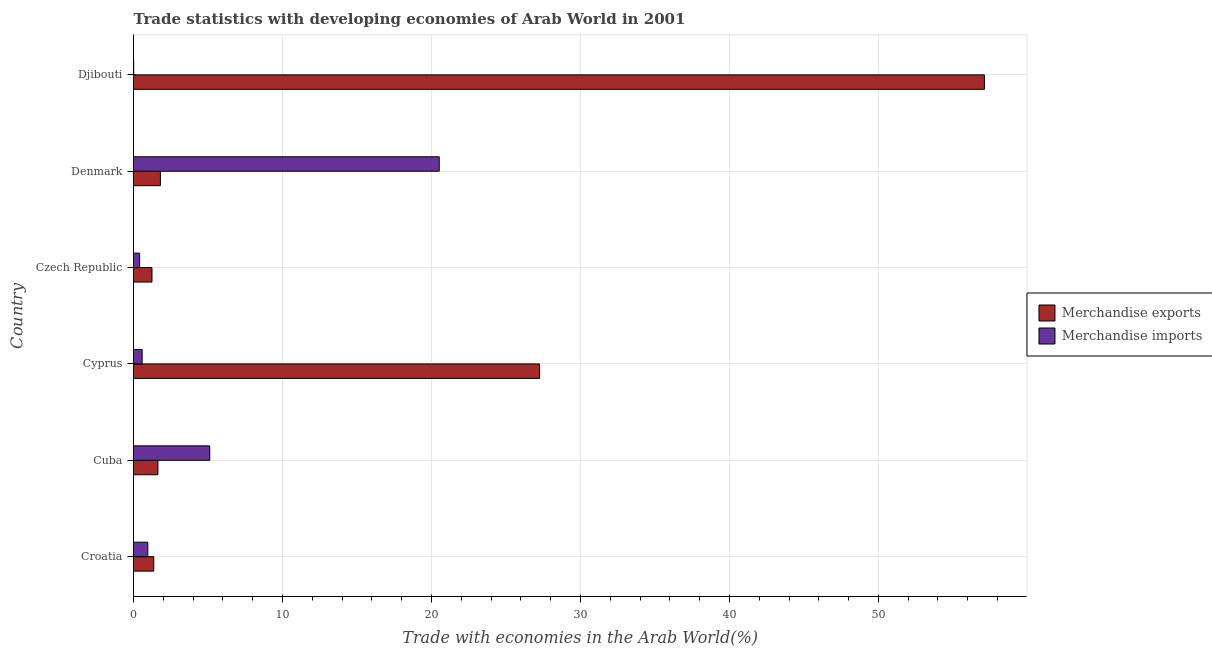How many groups of bars are there?
Your response must be concise. 6. Are the number of bars on each tick of the Y-axis equal?
Ensure brevity in your answer.  Yes. How many bars are there on the 3rd tick from the bottom?
Your answer should be compact. 2. What is the label of the 6th group of bars from the top?
Your answer should be compact. Croatia. What is the merchandise imports in Croatia?
Keep it short and to the point. 0.96. Across all countries, what is the maximum merchandise imports?
Your answer should be compact. 20.52. Across all countries, what is the minimum merchandise exports?
Ensure brevity in your answer.  1.24. In which country was the merchandise imports maximum?
Provide a short and direct response. Denmark. In which country was the merchandise imports minimum?
Your response must be concise. Djibouti. What is the total merchandise exports in the graph?
Your answer should be very brief. 90.42. What is the difference between the merchandise imports in Cuba and that in Denmark?
Make the answer very short. -15.4. What is the difference between the merchandise imports in Cuba and the merchandise exports in Denmark?
Provide a short and direct response. 3.31. What is the difference between the merchandise exports and merchandise imports in Czech Republic?
Give a very brief answer. 0.83. In how many countries, is the merchandise imports greater than 16 %?
Your response must be concise. 1. What is the ratio of the merchandise imports in Cyprus to that in Denmark?
Offer a terse response. 0.03. Is the difference between the merchandise imports in Croatia and Cyprus greater than the difference between the merchandise exports in Croatia and Cyprus?
Make the answer very short. Yes. What is the difference between the highest and the second highest merchandise imports?
Offer a very short reply. 15.4. What is the difference between the highest and the lowest merchandise imports?
Keep it short and to the point. 20.51. Is the sum of the merchandise exports in Cyprus and Djibouti greater than the maximum merchandise imports across all countries?
Provide a short and direct response. Yes. What does the 2nd bar from the top in Djibouti represents?
Make the answer very short. Merchandise exports. What does the 1st bar from the bottom in Croatia represents?
Your response must be concise. Merchandise exports. How many countries are there in the graph?
Offer a terse response. 6. Are the values on the major ticks of X-axis written in scientific E-notation?
Provide a succinct answer. No. Does the graph contain any zero values?
Your answer should be compact. No. Does the graph contain grids?
Offer a terse response. Yes. How many legend labels are there?
Provide a succinct answer. 2. What is the title of the graph?
Your response must be concise. Trade statistics with developing economies of Arab World in 2001. Does "Forest" appear as one of the legend labels in the graph?
Your answer should be very brief. No. What is the label or title of the X-axis?
Your answer should be compact. Trade with economies in the Arab World(%). What is the label or title of the Y-axis?
Your answer should be compact. Country. What is the Trade with economies in the Arab World(%) of Merchandise exports in Croatia?
Give a very brief answer. 1.36. What is the Trade with economies in the Arab World(%) of Merchandise imports in Croatia?
Your answer should be very brief. 0.96. What is the Trade with economies in the Arab World(%) of Merchandise exports in Cuba?
Provide a short and direct response. 1.64. What is the Trade with economies in the Arab World(%) in Merchandise imports in Cuba?
Your answer should be compact. 5.12. What is the Trade with economies in the Arab World(%) of Merchandise exports in Cyprus?
Your answer should be compact. 27.26. What is the Trade with economies in the Arab World(%) of Merchandise imports in Cyprus?
Give a very brief answer. 0.58. What is the Trade with economies in the Arab World(%) in Merchandise exports in Czech Republic?
Keep it short and to the point. 1.24. What is the Trade with economies in the Arab World(%) in Merchandise imports in Czech Republic?
Provide a succinct answer. 0.41. What is the Trade with economies in the Arab World(%) in Merchandise exports in Denmark?
Offer a terse response. 1.81. What is the Trade with economies in the Arab World(%) of Merchandise imports in Denmark?
Your answer should be very brief. 20.52. What is the Trade with economies in the Arab World(%) in Merchandise exports in Djibouti?
Offer a terse response. 57.12. What is the Trade with economies in the Arab World(%) in Merchandise imports in Djibouti?
Keep it short and to the point. 0.01. Across all countries, what is the maximum Trade with economies in the Arab World(%) in Merchandise exports?
Make the answer very short. 57.12. Across all countries, what is the maximum Trade with economies in the Arab World(%) of Merchandise imports?
Make the answer very short. 20.52. Across all countries, what is the minimum Trade with economies in the Arab World(%) of Merchandise exports?
Make the answer very short. 1.24. Across all countries, what is the minimum Trade with economies in the Arab World(%) in Merchandise imports?
Offer a very short reply. 0.01. What is the total Trade with economies in the Arab World(%) in Merchandise exports in the graph?
Offer a very short reply. 90.42. What is the total Trade with economies in the Arab World(%) in Merchandise imports in the graph?
Make the answer very short. 27.6. What is the difference between the Trade with economies in the Arab World(%) of Merchandise exports in Croatia and that in Cuba?
Provide a succinct answer. -0.28. What is the difference between the Trade with economies in the Arab World(%) in Merchandise imports in Croatia and that in Cuba?
Offer a very short reply. -4.16. What is the difference between the Trade with economies in the Arab World(%) of Merchandise exports in Croatia and that in Cyprus?
Make the answer very short. -25.9. What is the difference between the Trade with economies in the Arab World(%) in Merchandise imports in Croatia and that in Cyprus?
Give a very brief answer. 0.38. What is the difference between the Trade with economies in the Arab World(%) in Merchandise exports in Croatia and that in Czech Republic?
Offer a terse response. 0.12. What is the difference between the Trade with economies in the Arab World(%) in Merchandise imports in Croatia and that in Czech Republic?
Provide a short and direct response. 0.55. What is the difference between the Trade with economies in the Arab World(%) in Merchandise exports in Croatia and that in Denmark?
Your answer should be very brief. -0.45. What is the difference between the Trade with economies in the Arab World(%) of Merchandise imports in Croatia and that in Denmark?
Provide a succinct answer. -19.56. What is the difference between the Trade with economies in the Arab World(%) in Merchandise exports in Croatia and that in Djibouti?
Offer a very short reply. -55.76. What is the difference between the Trade with economies in the Arab World(%) in Merchandise imports in Croatia and that in Djibouti?
Provide a short and direct response. 0.95. What is the difference between the Trade with economies in the Arab World(%) of Merchandise exports in Cuba and that in Cyprus?
Your answer should be very brief. -25.62. What is the difference between the Trade with economies in the Arab World(%) of Merchandise imports in Cuba and that in Cyprus?
Your answer should be very brief. 4.54. What is the difference between the Trade with economies in the Arab World(%) in Merchandise exports in Cuba and that in Czech Republic?
Ensure brevity in your answer.  0.4. What is the difference between the Trade with economies in the Arab World(%) in Merchandise imports in Cuba and that in Czech Republic?
Make the answer very short. 4.7. What is the difference between the Trade with economies in the Arab World(%) in Merchandise exports in Cuba and that in Denmark?
Keep it short and to the point. -0.17. What is the difference between the Trade with economies in the Arab World(%) of Merchandise imports in Cuba and that in Denmark?
Your answer should be compact. -15.41. What is the difference between the Trade with economies in the Arab World(%) of Merchandise exports in Cuba and that in Djibouti?
Ensure brevity in your answer.  -55.48. What is the difference between the Trade with economies in the Arab World(%) in Merchandise imports in Cuba and that in Djibouti?
Your response must be concise. 5.11. What is the difference between the Trade with economies in the Arab World(%) of Merchandise exports in Cyprus and that in Czech Republic?
Your response must be concise. 26.02. What is the difference between the Trade with economies in the Arab World(%) of Merchandise imports in Cyprus and that in Czech Republic?
Ensure brevity in your answer.  0.17. What is the difference between the Trade with economies in the Arab World(%) of Merchandise exports in Cyprus and that in Denmark?
Provide a short and direct response. 25.45. What is the difference between the Trade with economies in the Arab World(%) in Merchandise imports in Cyprus and that in Denmark?
Your response must be concise. -19.94. What is the difference between the Trade with economies in the Arab World(%) of Merchandise exports in Cyprus and that in Djibouti?
Your answer should be very brief. -29.86. What is the difference between the Trade with economies in the Arab World(%) of Merchandise imports in Cyprus and that in Djibouti?
Offer a very short reply. 0.57. What is the difference between the Trade with economies in the Arab World(%) in Merchandise exports in Czech Republic and that in Denmark?
Your answer should be very brief. -0.57. What is the difference between the Trade with economies in the Arab World(%) in Merchandise imports in Czech Republic and that in Denmark?
Provide a succinct answer. -20.11. What is the difference between the Trade with economies in the Arab World(%) of Merchandise exports in Czech Republic and that in Djibouti?
Your answer should be very brief. -55.88. What is the difference between the Trade with economies in the Arab World(%) in Merchandise imports in Czech Republic and that in Djibouti?
Offer a very short reply. 0.4. What is the difference between the Trade with economies in the Arab World(%) of Merchandise exports in Denmark and that in Djibouti?
Make the answer very short. -55.31. What is the difference between the Trade with economies in the Arab World(%) in Merchandise imports in Denmark and that in Djibouti?
Ensure brevity in your answer.  20.51. What is the difference between the Trade with economies in the Arab World(%) in Merchandise exports in Croatia and the Trade with economies in the Arab World(%) in Merchandise imports in Cuba?
Your answer should be very brief. -3.76. What is the difference between the Trade with economies in the Arab World(%) in Merchandise exports in Croatia and the Trade with economies in the Arab World(%) in Merchandise imports in Cyprus?
Offer a terse response. 0.78. What is the difference between the Trade with economies in the Arab World(%) in Merchandise exports in Croatia and the Trade with economies in the Arab World(%) in Merchandise imports in Czech Republic?
Keep it short and to the point. 0.95. What is the difference between the Trade with economies in the Arab World(%) in Merchandise exports in Croatia and the Trade with economies in the Arab World(%) in Merchandise imports in Denmark?
Provide a succinct answer. -19.16. What is the difference between the Trade with economies in the Arab World(%) of Merchandise exports in Croatia and the Trade with economies in the Arab World(%) of Merchandise imports in Djibouti?
Your answer should be compact. 1.35. What is the difference between the Trade with economies in the Arab World(%) of Merchandise exports in Cuba and the Trade with economies in the Arab World(%) of Merchandise imports in Cyprus?
Your answer should be compact. 1.06. What is the difference between the Trade with economies in the Arab World(%) of Merchandise exports in Cuba and the Trade with economies in the Arab World(%) of Merchandise imports in Czech Republic?
Ensure brevity in your answer.  1.23. What is the difference between the Trade with economies in the Arab World(%) in Merchandise exports in Cuba and the Trade with economies in the Arab World(%) in Merchandise imports in Denmark?
Provide a short and direct response. -18.88. What is the difference between the Trade with economies in the Arab World(%) in Merchandise exports in Cuba and the Trade with economies in the Arab World(%) in Merchandise imports in Djibouti?
Provide a short and direct response. 1.63. What is the difference between the Trade with economies in the Arab World(%) in Merchandise exports in Cyprus and the Trade with economies in the Arab World(%) in Merchandise imports in Czech Republic?
Provide a short and direct response. 26.85. What is the difference between the Trade with economies in the Arab World(%) of Merchandise exports in Cyprus and the Trade with economies in the Arab World(%) of Merchandise imports in Denmark?
Keep it short and to the point. 6.73. What is the difference between the Trade with economies in the Arab World(%) of Merchandise exports in Cyprus and the Trade with economies in the Arab World(%) of Merchandise imports in Djibouti?
Your response must be concise. 27.25. What is the difference between the Trade with economies in the Arab World(%) of Merchandise exports in Czech Republic and the Trade with economies in the Arab World(%) of Merchandise imports in Denmark?
Give a very brief answer. -19.28. What is the difference between the Trade with economies in the Arab World(%) of Merchandise exports in Czech Republic and the Trade with economies in the Arab World(%) of Merchandise imports in Djibouti?
Offer a terse response. 1.23. What is the difference between the Trade with economies in the Arab World(%) of Merchandise exports in Denmark and the Trade with economies in the Arab World(%) of Merchandise imports in Djibouti?
Offer a very short reply. 1.8. What is the average Trade with economies in the Arab World(%) in Merchandise exports per country?
Provide a succinct answer. 15.07. What is the average Trade with economies in the Arab World(%) of Merchandise imports per country?
Provide a short and direct response. 4.6. What is the difference between the Trade with economies in the Arab World(%) of Merchandise exports and Trade with economies in the Arab World(%) of Merchandise imports in Croatia?
Your answer should be very brief. 0.4. What is the difference between the Trade with economies in the Arab World(%) in Merchandise exports and Trade with economies in the Arab World(%) in Merchandise imports in Cuba?
Provide a succinct answer. -3.48. What is the difference between the Trade with economies in the Arab World(%) of Merchandise exports and Trade with economies in the Arab World(%) of Merchandise imports in Cyprus?
Provide a succinct answer. 26.68. What is the difference between the Trade with economies in the Arab World(%) in Merchandise exports and Trade with economies in the Arab World(%) in Merchandise imports in Czech Republic?
Offer a very short reply. 0.83. What is the difference between the Trade with economies in the Arab World(%) in Merchandise exports and Trade with economies in the Arab World(%) in Merchandise imports in Denmark?
Give a very brief answer. -18.71. What is the difference between the Trade with economies in the Arab World(%) of Merchandise exports and Trade with economies in the Arab World(%) of Merchandise imports in Djibouti?
Provide a short and direct response. 57.11. What is the ratio of the Trade with economies in the Arab World(%) in Merchandise exports in Croatia to that in Cuba?
Ensure brevity in your answer.  0.83. What is the ratio of the Trade with economies in the Arab World(%) in Merchandise imports in Croatia to that in Cuba?
Provide a succinct answer. 0.19. What is the ratio of the Trade with economies in the Arab World(%) in Merchandise exports in Croatia to that in Cyprus?
Your answer should be compact. 0.05. What is the ratio of the Trade with economies in the Arab World(%) in Merchandise imports in Croatia to that in Cyprus?
Offer a terse response. 1.65. What is the ratio of the Trade with economies in the Arab World(%) of Merchandise exports in Croatia to that in Czech Republic?
Your response must be concise. 1.1. What is the ratio of the Trade with economies in the Arab World(%) of Merchandise imports in Croatia to that in Czech Republic?
Provide a succinct answer. 2.33. What is the ratio of the Trade with economies in the Arab World(%) of Merchandise exports in Croatia to that in Denmark?
Your answer should be very brief. 0.75. What is the ratio of the Trade with economies in the Arab World(%) in Merchandise imports in Croatia to that in Denmark?
Ensure brevity in your answer.  0.05. What is the ratio of the Trade with economies in the Arab World(%) of Merchandise exports in Croatia to that in Djibouti?
Provide a succinct answer. 0.02. What is the ratio of the Trade with economies in the Arab World(%) in Merchandise imports in Croatia to that in Djibouti?
Provide a succinct answer. 86.94. What is the ratio of the Trade with economies in the Arab World(%) in Merchandise exports in Cuba to that in Cyprus?
Your response must be concise. 0.06. What is the ratio of the Trade with economies in the Arab World(%) in Merchandise imports in Cuba to that in Cyprus?
Give a very brief answer. 8.82. What is the ratio of the Trade with economies in the Arab World(%) of Merchandise exports in Cuba to that in Czech Republic?
Keep it short and to the point. 1.32. What is the ratio of the Trade with economies in the Arab World(%) of Merchandise imports in Cuba to that in Czech Republic?
Offer a very short reply. 12.44. What is the ratio of the Trade with economies in the Arab World(%) of Merchandise exports in Cuba to that in Denmark?
Make the answer very short. 0.91. What is the ratio of the Trade with economies in the Arab World(%) of Merchandise imports in Cuba to that in Denmark?
Provide a short and direct response. 0.25. What is the ratio of the Trade with economies in the Arab World(%) in Merchandise exports in Cuba to that in Djibouti?
Make the answer very short. 0.03. What is the ratio of the Trade with economies in the Arab World(%) in Merchandise imports in Cuba to that in Djibouti?
Your answer should be compact. 463.63. What is the ratio of the Trade with economies in the Arab World(%) in Merchandise exports in Cyprus to that in Czech Republic?
Your answer should be very brief. 21.97. What is the ratio of the Trade with economies in the Arab World(%) in Merchandise imports in Cyprus to that in Czech Republic?
Offer a very short reply. 1.41. What is the ratio of the Trade with economies in the Arab World(%) of Merchandise exports in Cyprus to that in Denmark?
Offer a terse response. 15.08. What is the ratio of the Trade with economies in the Arab World(%) in Merchandise imports in Cyprus to that in Denmark?
Provide a succinct answer. 0.03. What is the ratio of the Trade with economies in the Arab World(%) in Merchandise exports in Cyprus to that in Djibouti?
Offer a very short reply. 0.48. What is the ratio of the Trade with economies in the Arab World(%) in Merchandise imports in Cyprus to that in Djibouti?
Give a very brief answer. 52.59. What is the ratio of the Trade with economies in the Arab World(%) of Merchandise exports in Czech Republic to that in Denmark?
Give a very brief answer. 0.69. What is the ratio of the Trade with economies in the Arab World(%) of Merchandise exports in Czech Republic to that in Djibouti?
Your answer should be compact. 0.02. What is the ratio of the Trade with economies in the Arab World(%) of Merchandise imports in Czech Republic to that in Djibouti?
Offer a very short reply. 37.27. What is the ratio of the Trade with economies in the Arab World(%) of Merchandise exports in Denmark to that in Djibouti?
Offer a terse response. 0.03. What is the ratio of the Trade with economies in the Arab World(%) in Merchandise imports in Denmark to that in Djibouti?
Ensure brevity in your answer.  1859.66. What is the difference between the highest and the second highest Trade with economies in the Arab World(%) in Merchandise exports?
Ensure brevity in your answer.  29.86. What is the difference between the highest and the second highest Trade with economies in the Arab World(%) of Merchandise imports?
Keep it short and to the point. 15.41. What is the difference between the highest and the lowest Trade with economies in the Arab World(%) of Merchandise exports?
Make the answer very short. 55.88. What is the difference between the highest and the lowest Trade with economies in the Arab World(%) of Merchandise imports?
Ensure brevity in your answer.  20.51. 